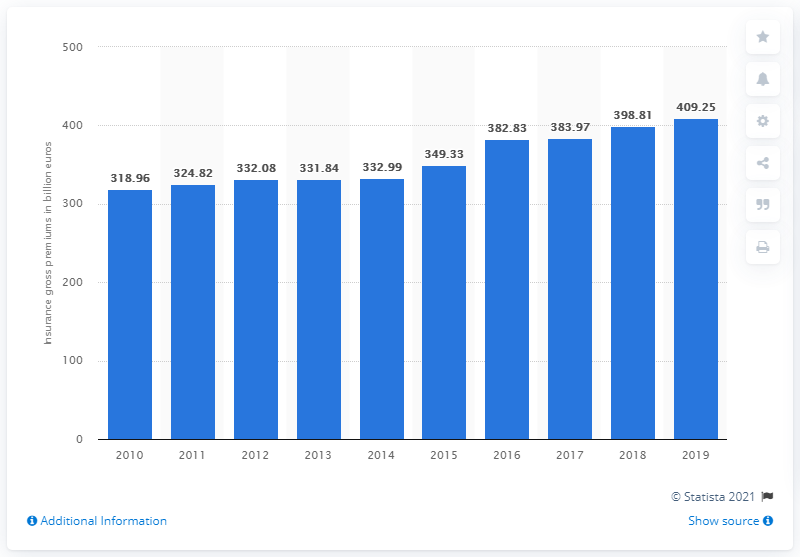List a handful of essential elements in this visual. In 2019, the total non-life premiums in Europe amounted to 409.25 billion euros. 